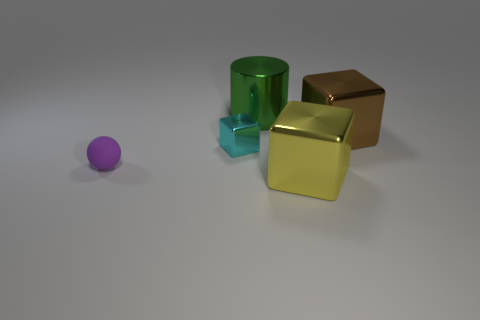Which object stands out the most to you, and why? The purple sphere stands out the most because its vibrant color contrasts with the muted colors of the other objects, and its shape is unique among the geometrical forms present. 